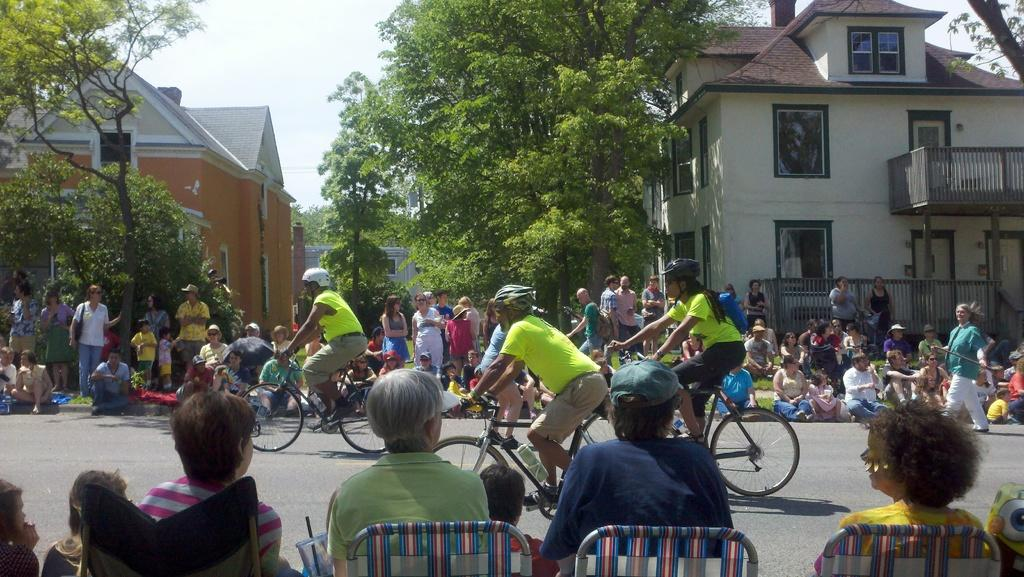What are the people in the image doing? There are people riding bicycles on the road. Are there any spectators in the image? Yes, people are watching the bicyclists. Where are the watchers positioned in relation to the road? The watchers are standing on either side of the road. What type of berry is being picked by the mother in the image? There is no mother or berry present in the image; it features people riding bicycles and watchers standing on either side of the road. 